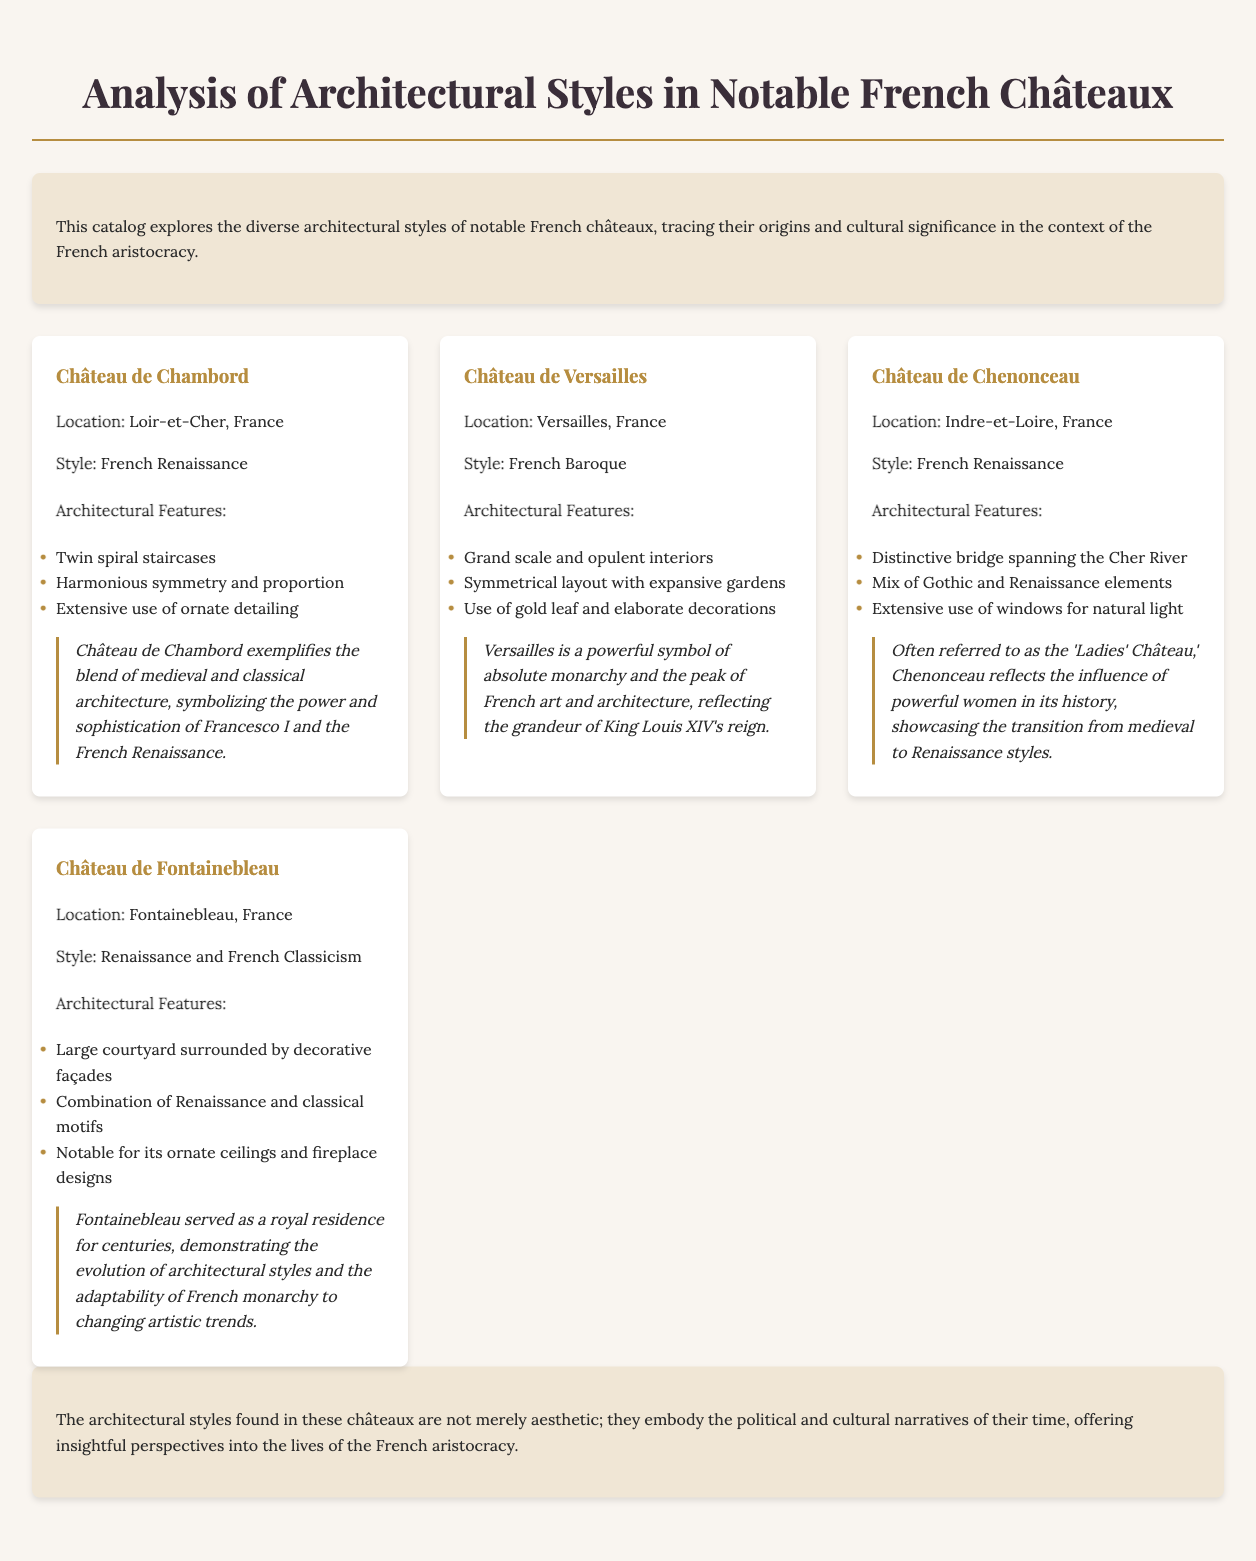What is the architectural style of Château de Chambord? The architectural style of Château de Chambord is specified in the document, which states it is French Renaissance.
Answer: French Renaissance Where is Château de Versailles located? The location of Château de Versailles is mentioned in the document as Versailles, France.
Answer: Versailles, France What significant feature is associated with Château de Chenonceau? The document mentions a "distinctive bridge spanning the Cher River" as a significant feature of Château de Chenonceau.
Answer: Distinctive bridge How many architectural styles are noted for Château de Fontainebleau? The document states that Château de Fontainebleau features two architectural styles: Renaissance and French Classicism.
Answer: Two What cultural significance is attributed to Château de Chambord? The document describes the cultural significance of Château de Chambord as symbolizing "the power and sophistication of Francesco I and the French Renaissance."
Answer: The power and sophistication of Francesco I Which château is often referred to as the 'Ladies' Château'? The document specifically refers to Château de Chenonceau as the 'Ladies' Château.'
Answer: Château de Chenonceau What is a notable interior feature of Château de Versailles? The document states that Château de Versailles showcases "grand scale and opulent interiors" as a notable interior feature.
Answer: Grand scale and opulent interiors What influences are reflected in the architecture of Château de Fontainebleau? The document notes that Château de Fontainebleau demonstrates "the evolution of architectural styles and the adaptability of French monarchy."
Answer: Evolution of architectural styles How many châteaux are analyzed in the document? The document lists four notable châteaux that are analyzed, providing insights into their styles and significance.
Answer: Four 